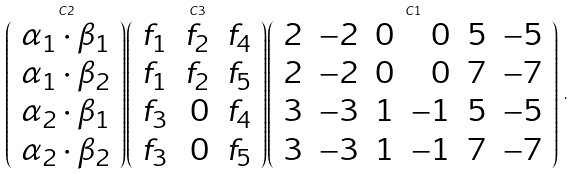<formula> <loc_0><loc_0><loc_500><loc_500>\stackrel { C 2 } { \left ( \begin{array} { r } \alpha _ { 1 } \cdot \beta _ { 1 } \\ \alpha _ { 1 } \cdot \beta _ { 2 } \\ \alpha _ { 2 } \cdot \beta _ { 1 } \\ \alpha _ { 2 } \cdot \beta _ { 2 } \end{array} \right ) } \stackrel { C 3 } { \left ( \begin{array} { r r r } f _ { 1 } & f _ { 2 } & f _ { 4 } \\ f _ { 1 } & f _ { 2 } & f _ { 5 } \\ f _ { 3 } & 0 & f _ { 4 } \\ f _ { 3 } & 0 & f _ { 5 } \end{array} \right ) } \stackrel { C 1 } { \left ( \begin{array} { r r r r r r } 2 & - 2 & 0 & 0 & 5 & - 5 \\ 2 & - 2 & 0 & 0 & 7 & - 7 \\ 3 & - 3 & 1 & - 1 & 5 & - 5 \\ 3 & - 3 & 1 & - 1 & 7 & - 7 \end{array} \right ) } \, .</formula> 